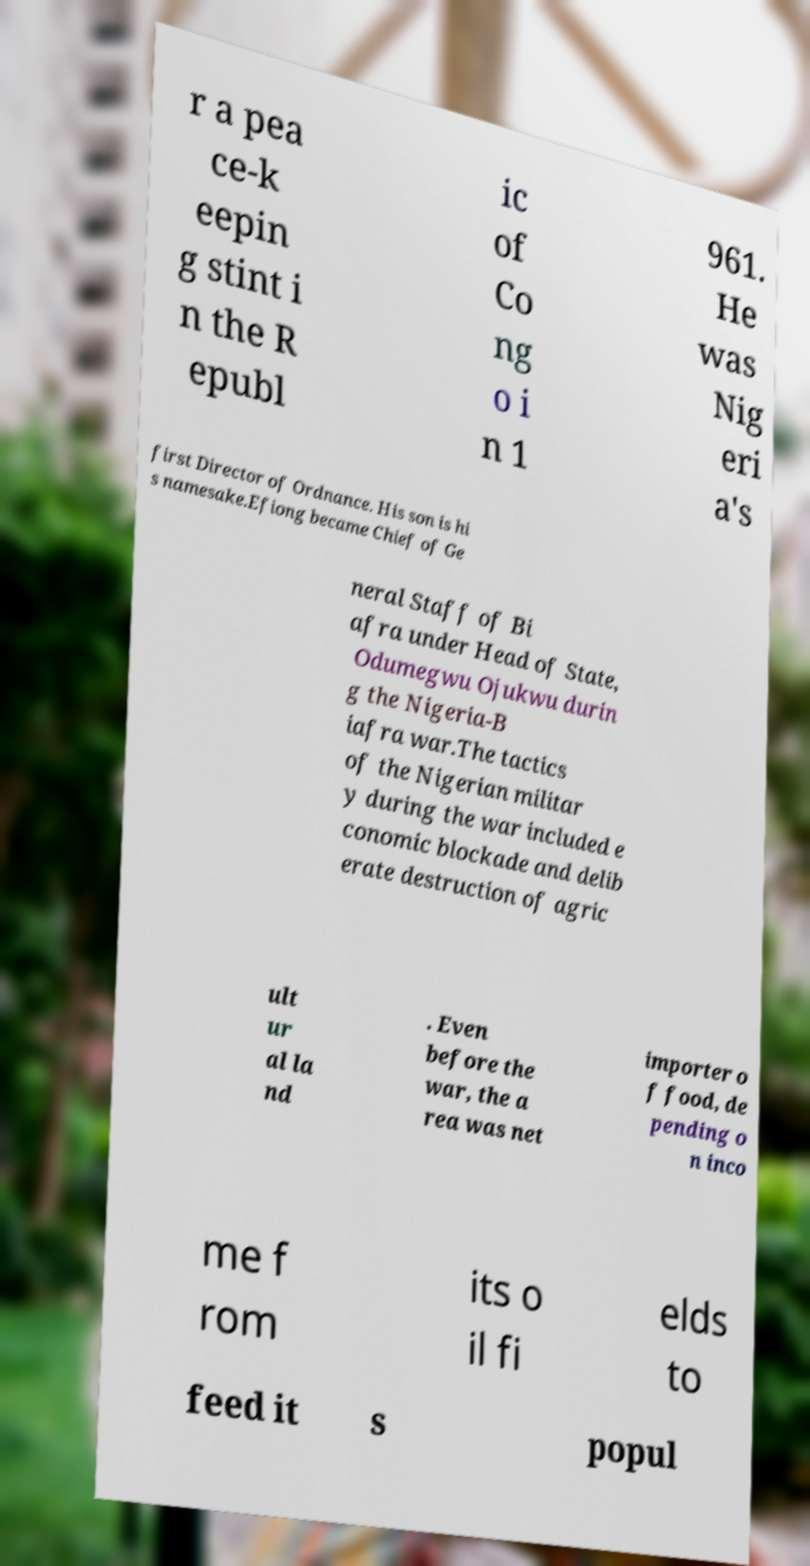Can you accurately transcribe the text from the provided image for me? r a pea ce-k eepin g stint i n the R epubl ic of Co ng o i n 1 961. He was Nig eri a's first Director of Ordnance. His son is hi s namesake.Efiong became Chief of Ge neral Staff of Bi afra under Head of State, Odumegwu Ojukwu durin g the Nigeria-B iafra war.The tactics of the Nigerian militar y during the war included e conomic blockade and delib erate destruction of agric ult ur al la nd . Even before the war, the a rea was net importer o f food, de pending o n inco me f rom its o il fi elds to feed it s popul 